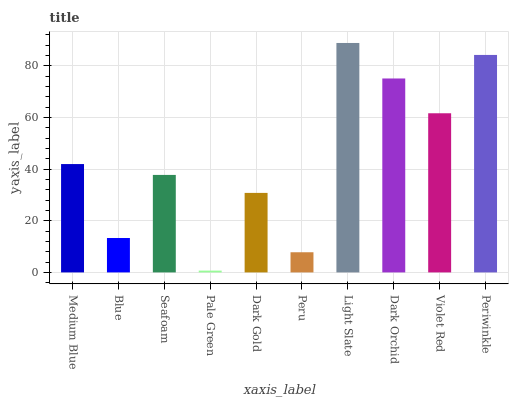Is Blue the minimum?
Answer yes or no. No. Is Blue the maximum?
Answer yes or no. No. Is Medium Blue greater than Blue?
Answer yes or no. Yes. Is Blue less than Medium Blue?
Answer yes or no. Yes. Is Blue greater than Medium Blue?
Answer yes or no. No. Is Medium Blue less than Blue?
Answer yes or no. No. Is Medium Blue the high median?
Answer yes or no. Yes. Is Seafoam the low median?
Answer yes or no. Yes. Is Periwinkle the high median?
Answer yes or no. No. Is Violet Red the low median?
Answer yes or no. No. 